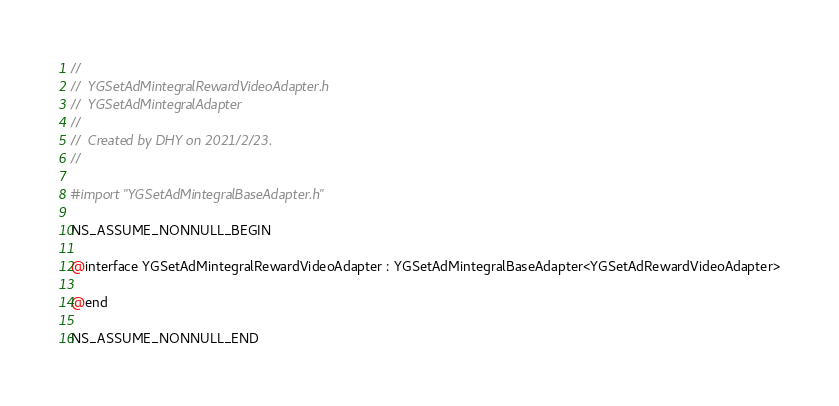Convert code to text. <code><loc_0><loc_0><loc_500><loc_500><_C_>//
//  YGSetAdMintegralRewardVideoAdapter.h
//  YGSetAdMintegralAdapter
//
//  Created by DHY on 2021/2/23.
//

#import "YGSetAdMintegralBaseAdapter.h"

NS_ASSUME_NONNULL_BEGIN

@interface YGSetAdMintegralRewardVideoAdapter : YGSetAdMintegralBaseAdapter<YGSetAdRewardVideoAdapter>

@end

NS_ASSUME_NONNULL_END
</code> 